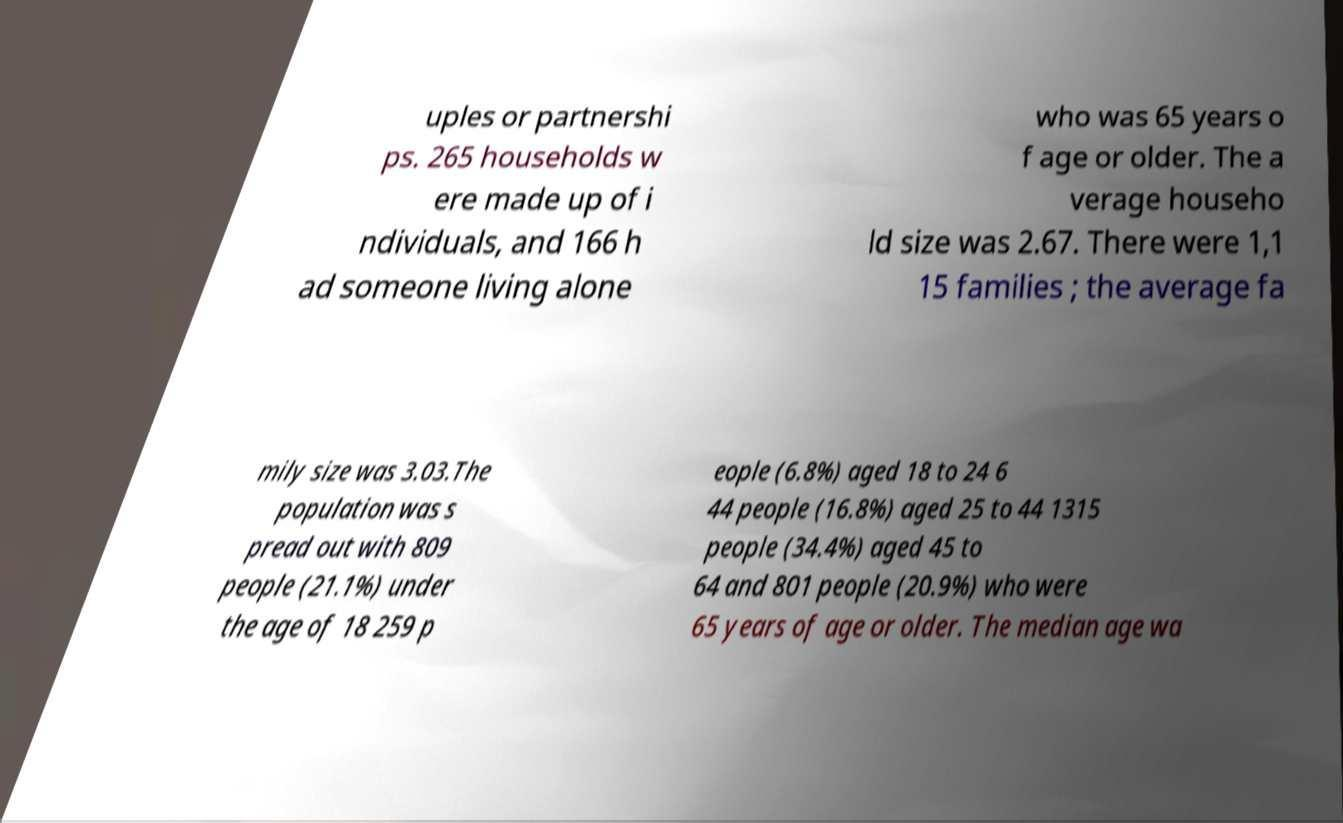Please identify and transcribe the text found in this image. uples or partnershi ps. 265 households w ere made up of i ndividuals, and 166 h ad someone living alone who was 65 years o f age or older. The a verage househo ld size was 2.67. There were 1,1 15 families ; the average fa mily size was 3.03.The population was s pread out with 809 people (21.1%) under the age of 18 259 p eople (6.8%) aged 18 to 24 6 44 people (16.8%) aged 25 to 44 1315 people (34.4%) aged 45 to 64 and 801 people (20.9%) who were 65 years of age or older. The median age wa 